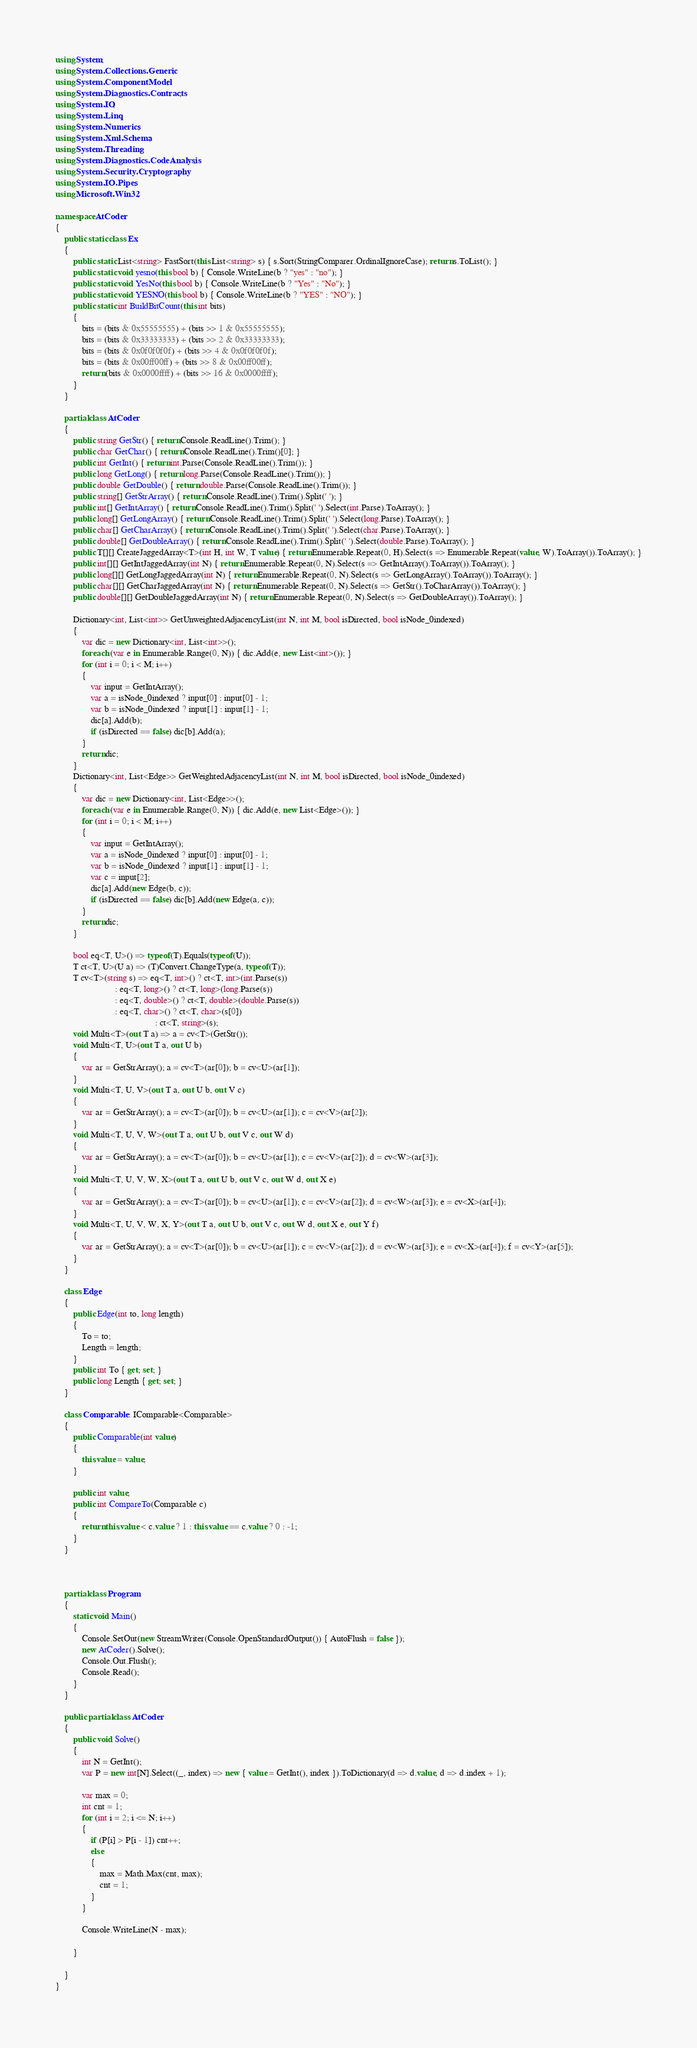<code> <loc_0><loc_0><loc_500><loc_500><_C#_>using System;
using System.Collections.Generic;
using System.ComponentModel;
using System.Diagnostics.Contracts;
using System.IO;
using System.Linq;
using System.Numerics;
using System.Xml.Schema;
using System.Threading;
using System.Diagnostics.CodeAnalysis;
using System.Security.Cryptography;
using System.IO.Pipes;
using Microsoft.Win32;

namespace AtCoder
{
    public static class Ex
    {
        public static List<string> FastSort(this List<string> s) { s.Sort(StringComparer.OrdinalIgnoreCase); return s.ToList(); }
        public static void yesno(this bool b) { Console.WriteLine(b ? "yes" : "no"); }
        public static void YesNo(this bool b) { Console.WriteLine(b ? "Yes" : "No"); }
        public static void YESNO(this bool b) { Console.WriteLine(b ? "YES" : "NO"); }
        public static int BuildBitCount(this int bits)
        {
            bits = (bits & 0x55555555) + (bits >> 1 & 0x55555555);
            bits = (bits & 0x33333333) + (bits >> 2 & 0x33333333);
            bits = (bits & 0x0f0f0f0f) + (bits >> 4 & 0x0f0f0f0f);
            bits = (bits & 0x00ff00ff) + (bits >> 8 & 0x00ff00ff);
            return (bits & 0x0000ffff) + (bits >> 16 & 0x0000ffff);
        }
    }

    partial class AtCoder
    {
        public string GetStr() { return Console.ReadLine().Trim(); }
        public char GetChar() { return Console.ReadLine().Trim()[0]; }
        public int GetInt() { return int.Parse(Console.ReadLine().Trim()); }
        public long GetLong() { return long.Parse(Console.ReadLine().Trim()); }
        public double GetDouble() { return double.Parse(Console.ReadLine().Trim()); }
        public string[] GetStrArray() { return Console.ReadLine().Trim().Split(' '); }
        public int[] GetIntArray() { return Console.ReadLine().Trim().Split(' ').Select(int.Parse).ToArray(); }
        public long[] GetLongArray() { return Console.ReadLine().Trim().Split(' ').Select(long.Parse).ToArray(); }
        public char[] GetCharArray() { return Console.ReadLine().Trim().Split(' ').Select(char.Parse).ToArray(); }
        public double[] GetDoubleArray() { return Console.ReadLine().Trim().Split(' ').Select(double.Parse).ToArray(); }
        public T[][] CreateJaggedArray<T>(int H, int W, T value) { return Enumerable.Repeat(0, H).Select(s => Enumerable.Repeat(value, W).ToArray()).ToArray(); }
        public int[][] GetIntJaggedArray(int N) { return Enumerable.Repeat(0, N).Select(s => GetIntArray().ToArray()).ToArray(); }
        public long[][] GetLongJaggedArray(int N) { return Enumerable.Repeat(0, N).Select(s => GetLongArray().ToArray()).ToArray(); }
        public char[][] GetCharJaggedArray(int N) { return Enumerable.Repeat(0, N).Select(s => GetStr().ToCharArray()).ToArray(); }
        public double[][] GetDoubleJaggedArray(int N) { return Enumerable.Repeat(0, N).Select(s => GetDoubleArray()).ToArray(); }

        Dictionary<int, List<int>> GetUnweightedAdjacencyList(int N, int M, bool isDirected, bool isNode_0indexed)
        {
            var dic = new Dictionary<int, List<int>>();
            foreach (var e in Enumerable.Range(0, N)) { dic.Add(e, new List<int>()); }
            for (int i = 0; i < M; i++)
            {
                var input = GetIntArray();
                var a = isNode_0indexed ? input[0] : input[0] - 1;
                var b = isNode_0indexed ? input[1] : input[1] - 1;
                dic[a].Add(b);
                if (isDirected == false) dic[b].Add(a);
            }
            return dic;
        }
        Dictionary<int, List<Edge>> GetWeightedAdjacencyList(int N, int M, bool isDirected, bool isNode_0indexed)
        {
            var dic = new Dictionary<int, List<Edge>>();
            foreach (var e in Enumerable.Range(0, N)) { dic.Add(e, new List<Edge>()); }
            for (int i = 0; i < M; i++)
            {
                var input = GetIntArray();
                var a = isNode_0indexed ? input[0] : input[0] - 1;
                var b = isNode_0indexed ? input[1] : input[1] - 1;
                var c = input[2];
                dic[a].Add(new Edge(b, c));
                if (isDirected == false) dic[b].Add(new Edge(a, c));
            }
            return dic;
        }

        bool eq<T, U>() => typeof(T).Equals(typeof(U));
        T ct<T, U>(U a) => (T)Convert.ChangeType(a, typeof(T));
        T cv<T>(string s) => eq<T, int>() ? ct<T, int>(int.Parse(s))
                           : eq<T, long>() ? ct<T, long>(long.Parse(s))
                           : eq<T, double>() ? ct<T, double>(double.Parse(s))
                           : eq<T, char>() ? ct<T, char>(s[0])
                                             : ct<T, string>(s);
        void Multi<T>(out T a) => a = cv<T>(GetStr());
        void Multi<T, U>(out T a, out U b)
        {
            var ar = GetStrArray(); a = cv<T>(ar[0]); b = cv<U>(ar[1]);
        }
        void Multi<T, U, V>(out T a, out U b, out V c)
        {
            var ar = GetStrArray(); a = cv<T>(ar[0]); b = cv<U>(ar[1]); c = cv<V>(ar[2]);
        }
        void Multi<T, U, V, W>(out T a, out U b, out V c, out W d)
        {
            var ar = GetStrArray(); a = cv<T>(ar[0]); b = cv<U>(ar[1]); c = cv<V>(ar[2]); d = cv<W>(ar[3]);
        }
        void Multi<T, U, V, W, X>(out T a, out U b, out V c, out W d, out X e)
        {
            var ar = GetStrArray(); a = cv<T>(ar[0]); b = cv<U>(ar[1]); c = cv<V>(ar[2]); d = cv<W>(ar[3]); e = cv<X>(ar[4]);
        }
        void Multi<T, U, V, W, X, Y>(out T a, out U b, out V c, out W d, out X e, out Y f)
        {
            var ar = GetStrArray(); a = cv<T>(ar[0]); b = cv<U>(ar[1]); c = cv<V>(ar[2]); d = cv<W>(ar[3]); e = cv<X>(ar[4]); f = cv<Y>(ar[5]);
        }
    }

    class Edge
    {
        public Edge(int to, long length)
        {
            To = to;
            Length = length;
        }
        public int To { get; set; }
        public long Length { get; set; }
    }

    class Comparable : IComparable<Comparable>
    {
        public Comparable(int value)
        {
            this.value = value;
        }

        public int value;
        public int CompareTo(Comparable c)
        {
            return this.value < c.value ? 1 : this.value == c.value ? 0 : -1;
        }
    }



    partial class Program
    {
        static void Main()
        {
            Console.SetOut(new StreamWriter(Console.OpenStandardOutput()) { AutoFlush = false });
            new AtCoder().Solve();
            Console.Out.Flush();
            Console.Read();
        }
    }

    public partial class AtCoder
    {
        public void Solve()
        {
            int N = GetInt();
            var P = new int[N].Select((_, index) => new { value = GetInt(), index }).ToDictionary(d => d.value, d => d.index + 1);

            var max = 0;
            int cnt = 1;
            for (int i = 2; i <= N; i++)
            {
                if (P[i] > P[i - 1]) cnt++;
                else
                {
                    max = Math.Max(cnt, max);
                    cnt = 1;
                }
            }

            Console.WriteLine(N - max);

        }

    }
}
</code> 